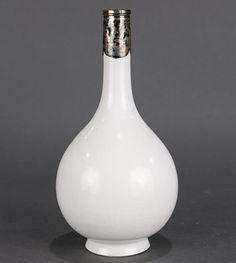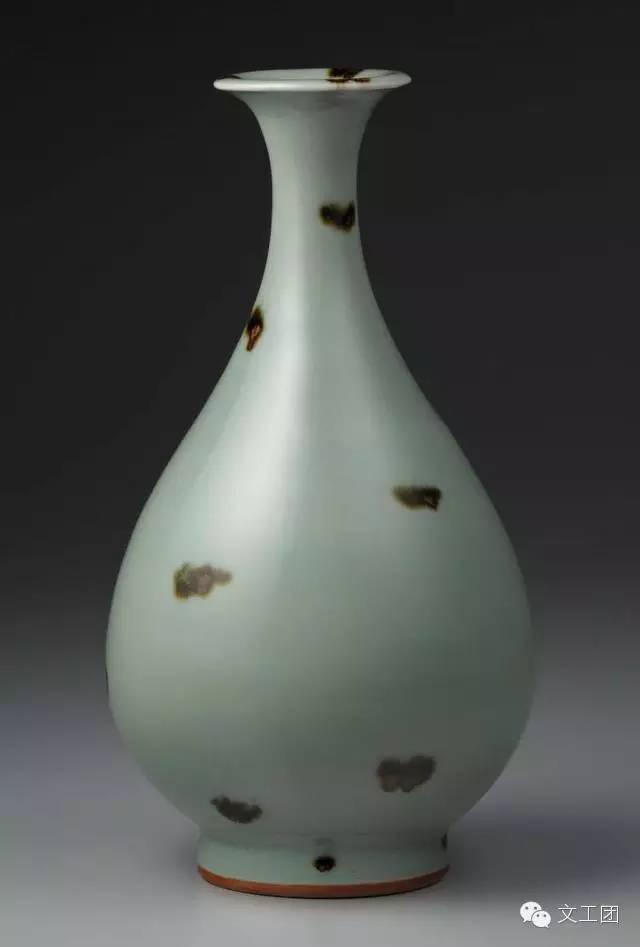The first image is the image on the left, the second image is the image on the right. Evaluate the accuracy of this statement regarding the images: "Each vase has a round pair shaped base with a skinny neck and a fluted opening at the top.". Is it true? Answer yes or no. No. The first image is the image on the left, the second image is the image on the right. Given the left and right images, does the statement "One of the images shows a plain white vase." hold true? Answer yes or no. Yes. 